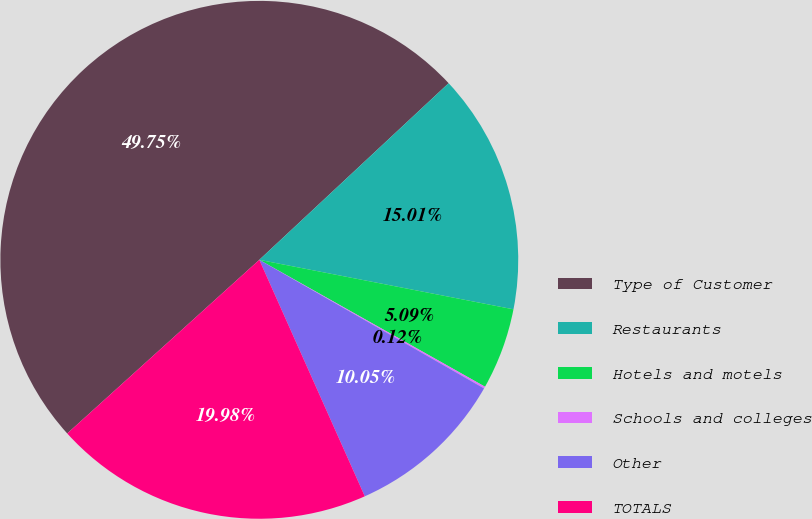Convert chart to OTSL. <chart><loc_0><loc_0><loc_500><loc_500><pie_chart><fcel>Type of Customer<fcel>Restaurants<fcel>Hotels and motels<fcel>Schools and colleges<fcel>Other<fcel>TOTALS<nl><fcel>49.75%<fcel>15.01%<fcel>5.09%<fcel>0.12%<fcel>10.05%<fcel>19.98%<nl></chart> 